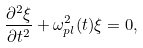Convert formula to latex. <formula><loc_0><loc_0><loc_500><loc_500>\frac { \partial ^ { 2 } \xi } { \partial t ^ { 2 } } + \omega _ { p l } ^ { 2 } ( t ) \xi = 0 ,</formula> 